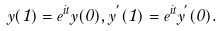<formula> <loc_0><loc_0><loc_500><loc_500>y ( 1 ) = e ^ { i t } y ( 0 ) , y ^ { ^ { \prime } } ( 1 ) = e ^ { i t } y ^ { ^ { \prime } } ( 0 ) .</formula> 